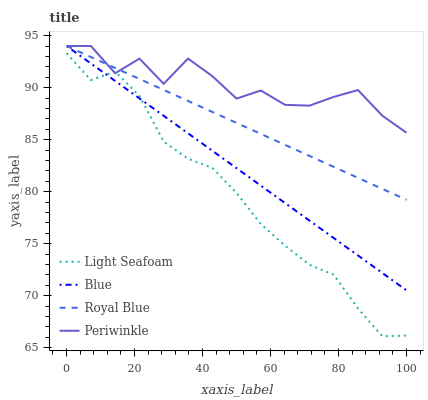Does Light Seafoam have the minimum area under the curve?
Answer yes or no. Yes. Does Periwinkle have the maximum area under the curve?
Answer yes or no. Yes. Does Royal Blue have the minimum area under the curve?
Answer yes or no. No. Does Royal Blue have the maximum area under the curve?
Answer yes or no. No. Is Blue the smoothest?
Answer yes or no. Yes. Is Periwinkle the roughest?
Answer yes or no. Yes. Is Royal Blue the smoothest?
Answer yes or no. No. Is Royal Blue the roughest?
Answer yes or no. No. Does Royal Blue have the lowest value?
Answer yes or no. No. Does Periwinkle have the highest value?
Answer yes or no. Yes. Does Light Seafoam have the highest value?
Answer yes or no. No. Is Light Seafoam less than Royal Blue?
Answer yes or no. Yes. Is Royal Blue greater than Light Seafoam?
Answer yes or no. Yes. Does Periwinkle intersect Light Seafoam?
Answer yes or no. Yes. Is Periwinkle less than Light Seafoam?
Answer yes or no. No. Is Periwinkle greater than Light Seafoam?
Answer yes or no. No. Does Light Seafoam intersect Royal Blue?
Answer yes or no. No. 